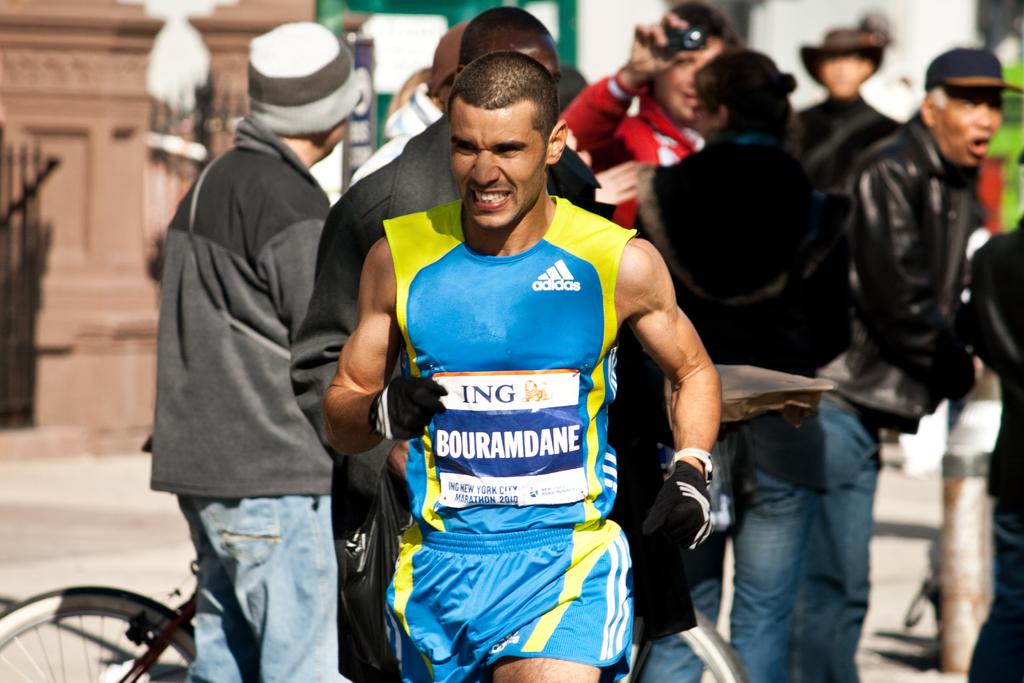What brand is his muscle shirt?
Keep it short and to the point. Adidas. 